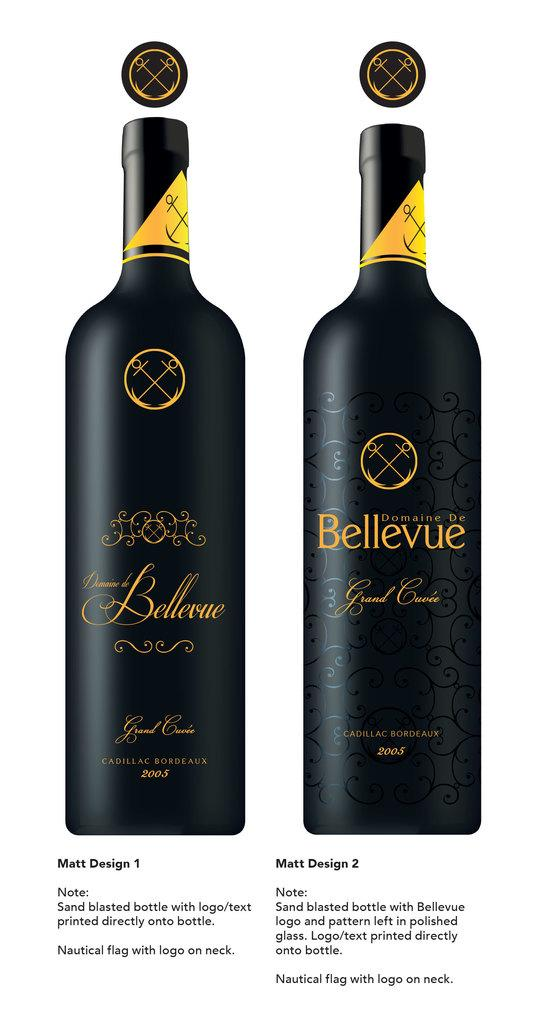How many bottles are visible in the image? There are two bottles in the image. What is located beneath the bottles? There is text under the bottles. What type of test is being conducted with the bottles in the image? There is no indication of a test being conducted in the image; it only shows two bottles and text beneath them. 